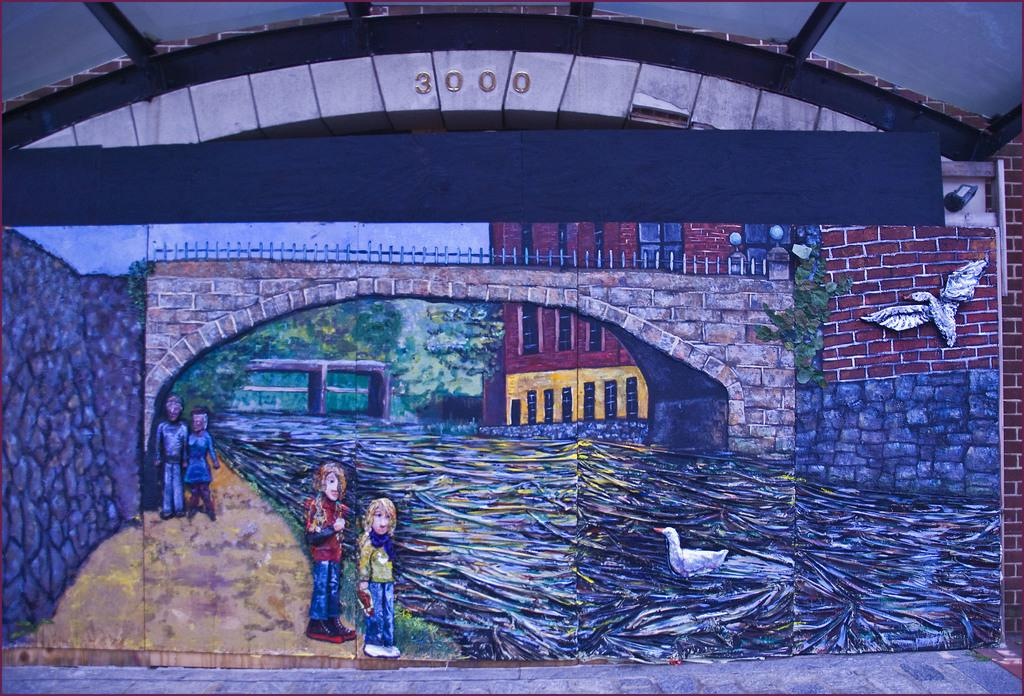What is the main subject of the image? The main subject of the image is a painting. What elements are included in the painting? The painting includes water, birds, people, trees, and buildings. Are there any numbers written above the painting in the image? Yes, there are numbers written above the painting in the image. What type of breakfast is being served in the painting? There is no breakfast depicted in the painting; it features water, birds, people, trees, and buildings. Can you describe the brain of the bird in the painting? There is no bird with a visible brain in the painting; it only includes birds as a general element. 